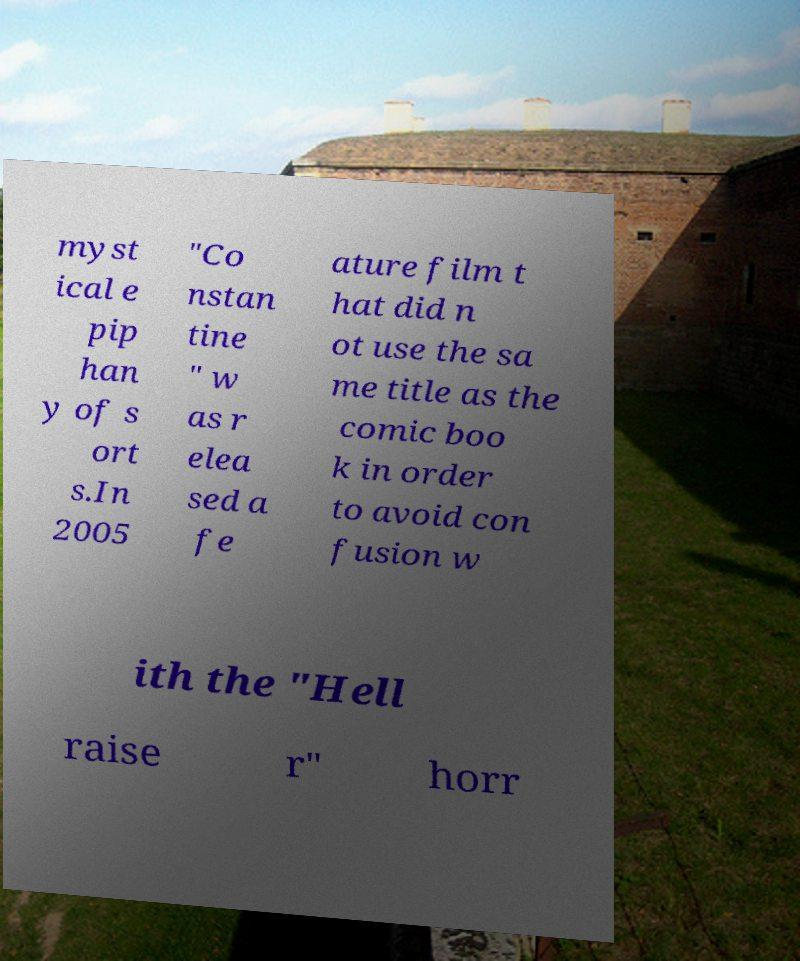I need the written content from this picture converted into text. Can you do that? myst ical e pip han y of s ort s.In 2005 "Co nstan tine " w as r elea sed a fe ature film t hat did n ot use the sa me title as the comic boo k in order to avoid con fusion w ith the "Hell raise r" horr 